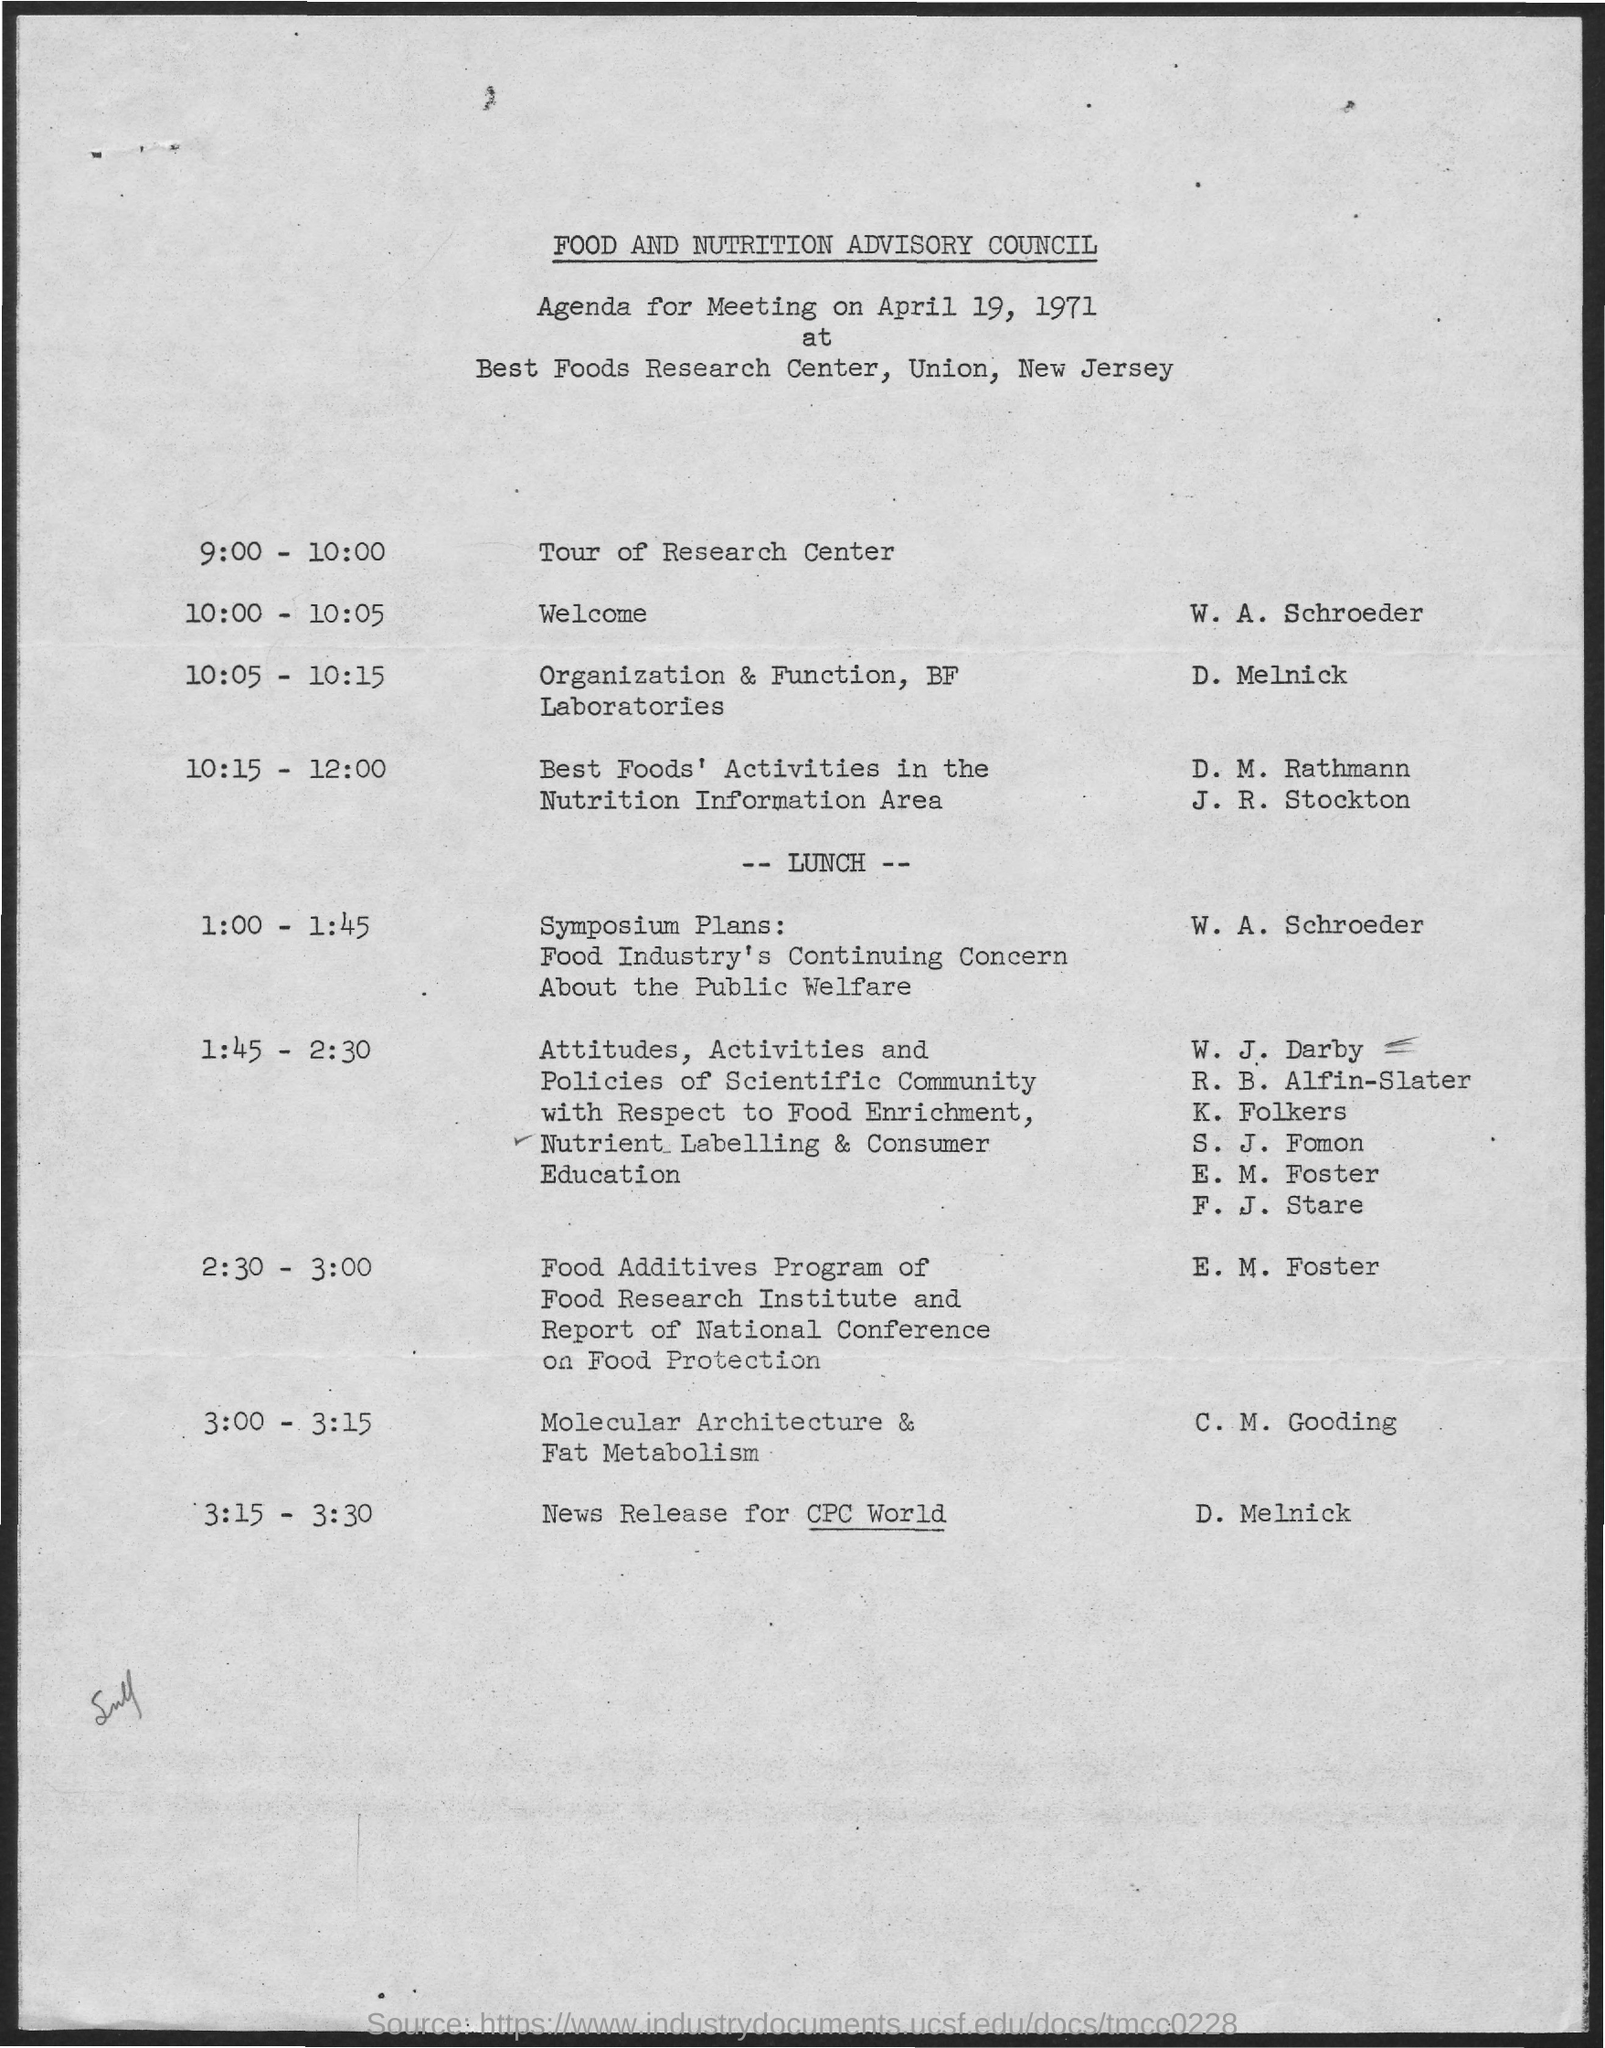Mention a couple of crucial points in this snapshot. The welcome event will take place from 10:00 to 10:05. The presenter of the news release for CPC World is D. Melnick. The tour of the research center will take place between 9:00 and 10:00. The meeting is held in Union, New Jersey. The speaker is announcing that W. A. Schroeder will be presenting a welcome. 